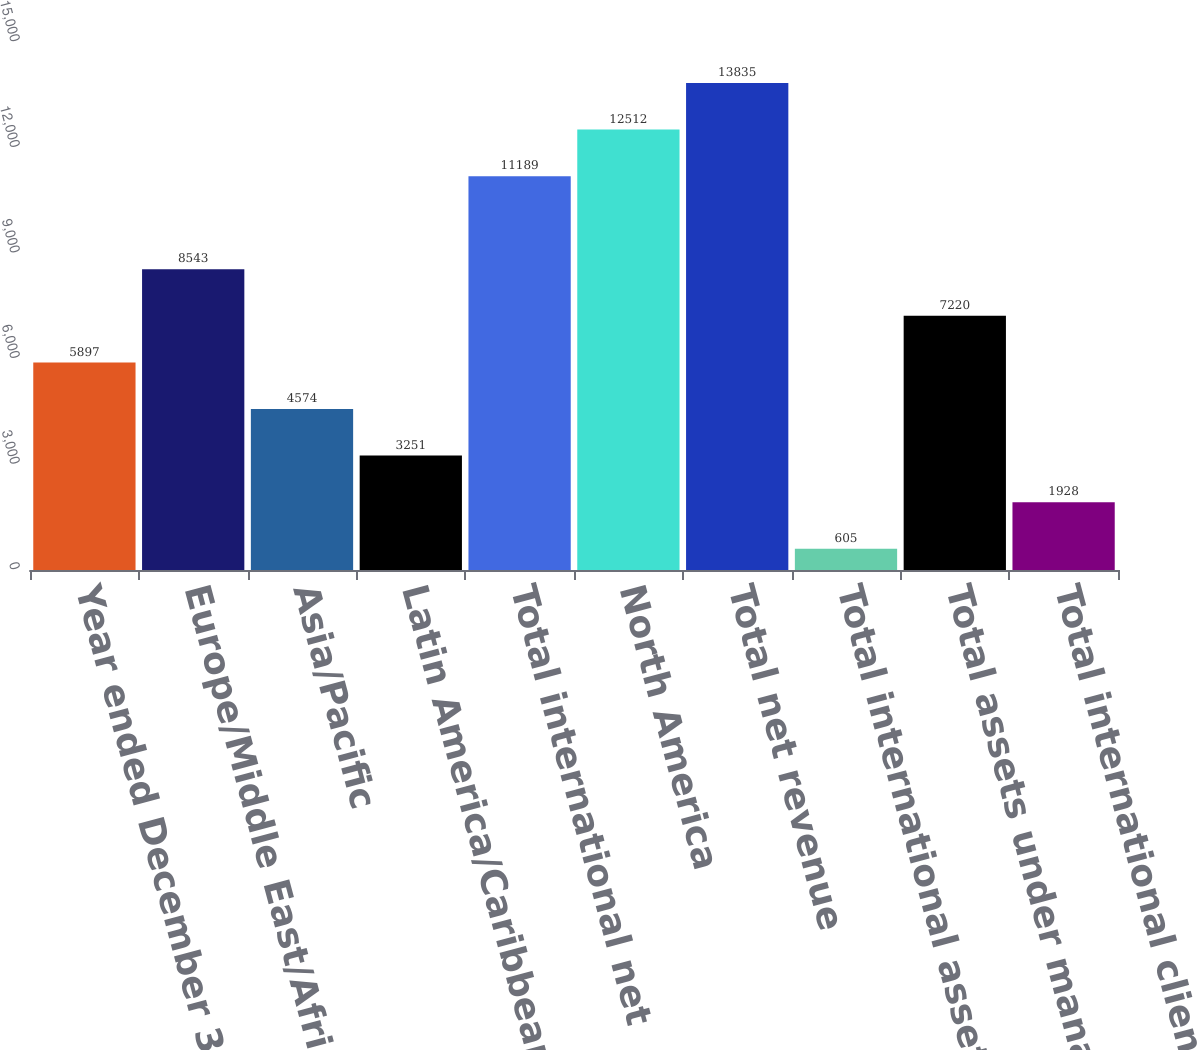<chart> <loc_0><loc_0><loc_500><loc_500><bar_chart><fcel>Year ended December 31 (in<fcel>Europe/Middle East/Africa<fcel>Asia/Pacific<fcel>Latin America/Caribbean<fcel>Total international net<fcel>North America<fcel>Total net revenue<fcel>Total international assets<fcel>Total assets under management<fcel>Total international client<nl><fcel>5897<fcel>8543<fcel>4574<fcel>3251<fcel>11189<fcel>12512<fcel>13835<fcel>605<fcel>7220<fcel>1928<nl></chart> 